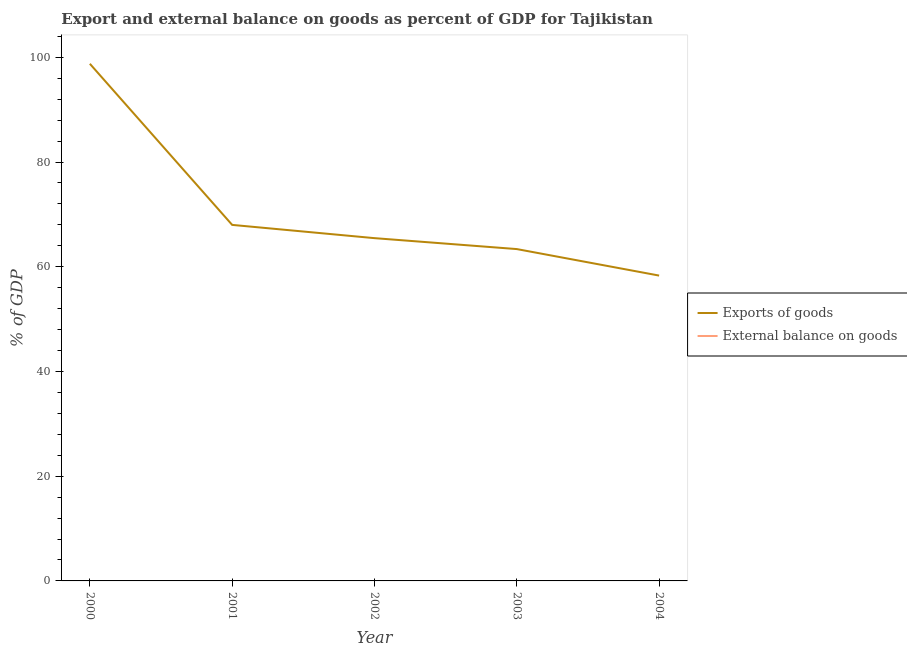Does the line corresponding to export of goods as percentage of gdp intersect with the line corresponding to external balance on goods as percentage of gdp?
Offer a very short reply. No. What is the export of goods as percentage of gdp in 2001?
Your response must be concise. 67.99. Across all years, what is the maximum export of goods as percentage of gdp?
Make the answer very short. 98.76. What is the difference between the export of goods as percentage of gdp in 2002 and that in 2004?
Provide a short and direct response. 7.15. What is the difference between the external balance on goods as percentage of gdp in 2000 and the export of goods as percentage of gdp in 2001?
Your answer should be compact. -67.99. What is the average export of goods as percentage of gdp per year?
Provide a short and direct response. 70.78. What is the ratio of the export of goods as percentage of gdp in 2000 to that in 2001?
Your answer should be compact. 1.45. What is the difference between the highest and the second highest export of goods as percentage of gdp?
Give a very brief answer. 30.77. What is the difference between the highest and the lowest export of goods as percentage of gdp?
Make the answer very short. 40.45. Is the sum of the export of goods as percentage of gdp in 2000 and 2001 greater than the maximum external balance on goods as percentage of gdp across all years?
Offer a terse response. Yes. Does the graph contain any zero values?
Ensure brevity in your answer.  Yes. Does the graph contain grids?
Provide a short and direct response. No. How are the legend labels stacked?
Give a very brief answer. Vertical. What is the title of the graph?
Give a very brief answer. Export and external balance on goods as percent of GDP for Tajikistan. Does "Techinal cooperation" appear as one of the legend labels in the graph?
Make the answer very short. No. What is the label or title of the Y-axis?
Your answer should be compact. % of GDP. What is the % of GDP in Exports of goods in 2000?
Offer a very short reply. 98.76. What is the % of GDP in Exports of goods in 2001?
Your response must be concise. 67.99. What is the % of GDP in Exports of goods in 2002?
Provide a succinct answer. 65.46. What is the % of GDP of External balance on goods in 2002?
Offer a very short reply. 0. What is the % of GDP in Exports of goods in 2003?
Offer a very short reply. 63.37. What is the % of GDP in Exports of goods in 2004?
Make the answer very short. 58.31. What is the % of GDP of External balance on goods in 2004?
Your answer should be compact. 0. Across all years, what is the maximum % of GDP of Exports of goods?
Offer a very short reply. 98.76. Across all years, what is the minimum % of GDP in Exports of goods?
Your answer should be very brief. 58.31. What is the total % of GDP in Exports of goods in the graph?
Provide a succinct answer. 353.9. What is the total % of GDP of External balance on goods in the graph?
Keep it short and to the point. 0. What is the difference between the % of GDP in Exports of goods in 2000 and that in 2001?
Provide a short and direct response. 30.77. What is the difference between the % of GDP in Exports of goods in 2000 and that in 2002?
Ensure brevity in your answer.  33.3. What is the difference between the % of GDP in Exports of goods in 2000 and that in 2003?
Keep it short and to the point. 35.39. What is the difference between the % of GDP in Exports of goods in 2000 and that in 2004?
Give a very brief answer. 40.45. What is the difference between the % of GDP in Exports of goods in 2001 and that in 2002?
Your response must be concise. 2.53. What is the difference between the % of GDP of Exports of goods in 2001 and that in 2003?
Offer a terse response. 4.62. What is the difference between the % of GDP of Exports of goods in 2001 and that in 2004?
Offer a terse response. 9.68. What is the difference between the % of GDP in Exports of goods in 2002 and that in 2003?
Offer a very short reply. 2.09. What is the difference between the % of GDP in Exports of goods in 2002 and that in 2004?
Provide a succinct answer. 7.15. What is the difference between the % of GDP of Exports of goods in 2003 and that in 2004?
Keep it short and to the point. 5.06. What is the average % of GDP in Exports of goods per year?
Offer a terse response. 70.78. What is the average % of GDP of External balance on goods per year?
Keep it short and to the point. 0. What is the ratio of the % of GDP of Exports of goods in 2000 to that in 2001?
Make the answer very short. 1.45. What is the ratio of the % of GDP of Exports of goods in 2000 to that in 2002?
Provide a short and direct response. 1.51. What is the ratio of the % of GDP of Exports of goods in 2000 to that in 2003?
Offer a terse response. 1.56. What is the ratio of the % of GDP of Exports of goods in 2000 to that in 2004?
Offer a very short reply. 1.69. What is the ratio of the % of GDP in Exports of goods in 2001 to that in 2002?
Provide a short and direct response. 1.04. What is the ratio of the % of GDP of Exports of goods in 2001 to that in 2003?
Offer a very short reply. 1.07. What is the ratio of the % of GDP in Exports of goods in 2001 to that in 2004?
Give a very brief answer. 1.17. What is the ratio of the % of GDP in Exports of goods in 2002 to that in 2003?
Provide a succinct answer. 1.03. What is the ratio of the % of GDP of Exports of goods in 2002 to that in 2004?
Your response must be concise. 1.12. What is the ratio of the % of GDP of Exports of goods in 2003 to that in 2004?
Your answer should be compact. 1.09. What is the difference between the highest and the second highest % of GDP in Exports of goods?
Offer a terse response. 30.77. What is the difference between the highest and the lowest % of GDP of Exports of goods?
Give a very brief answer. 40.45. 